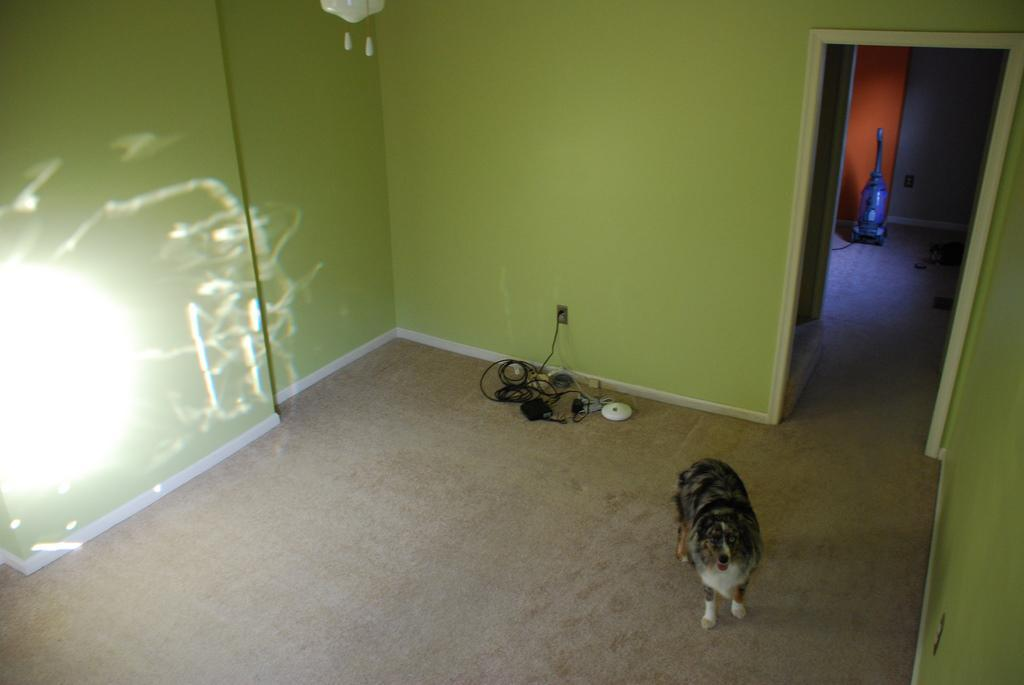What type of animal is present in the image? There is a dog in the image. What is located at the bottom of the image? There is a carpet at the bottom of the image. What can be seen in the background of the image? There is a wall in the background of the image. Where is the door located in the image? The door is on the right side of the image. What type of pot is visible on the dog's head in the image? There is no pot present on the dog's head in the image. 